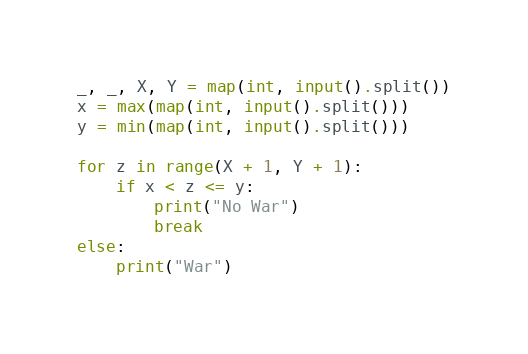<code> <loc_0><loc_0><loc_500><loc_500><_Python_>_, _, X, Y = map(int, input().split())
x = max(map(int, input().split()))
y = min(map(int, input().split()))

for z in range(X + 1, Y + 1):
    if x < z <= y:
        print("No War")
        break
else:
    print("War")</code> 